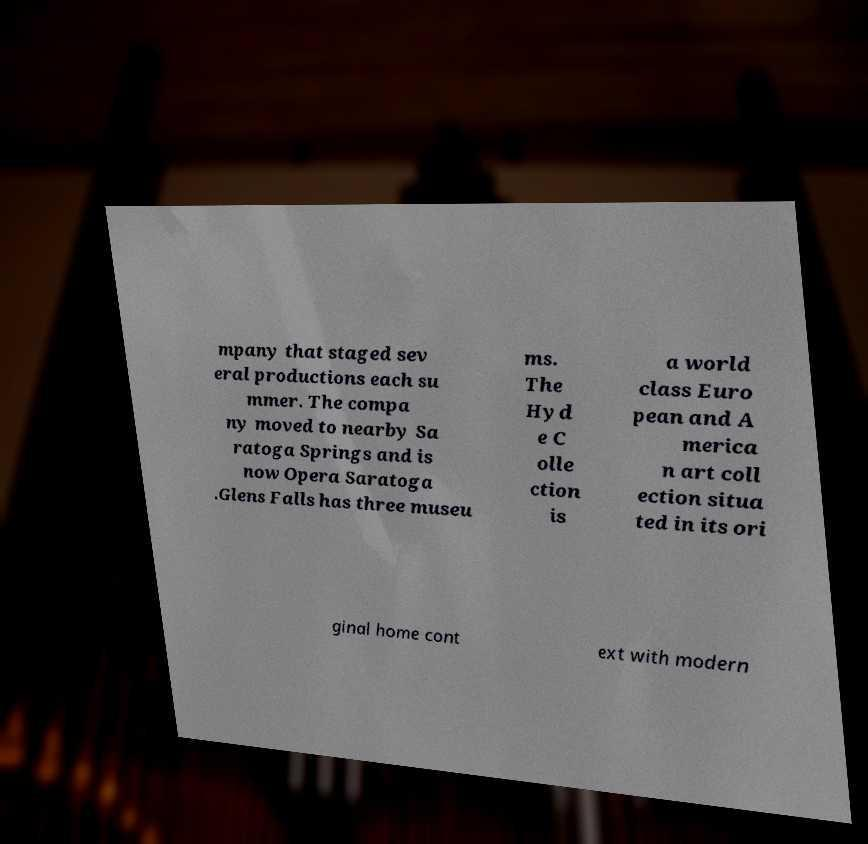Can you read and provide the text displayed in the image?This photo seems to have some interesting text. Can you extract and type it out for me? mpany that staged sev eral productions each su mmer. The compa ny moved to nearby Sa ratoga Springs and is now Opera Saratoga .Glens Falls has three museu ms. The Hyd e C olle ction is a world class Euro pean and A merica n art coll ection situa ted in its ori ginal home cont ext with modern 